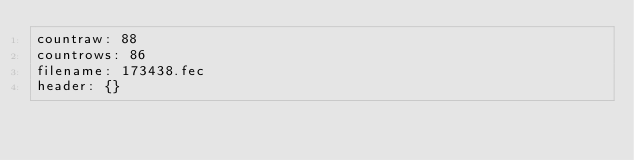<code> <loc_0><loc_0><loc_500><loc_500><_YAML_>countraw: 88
countrows: 86
filename: 173438.fec
header: {}</code> 